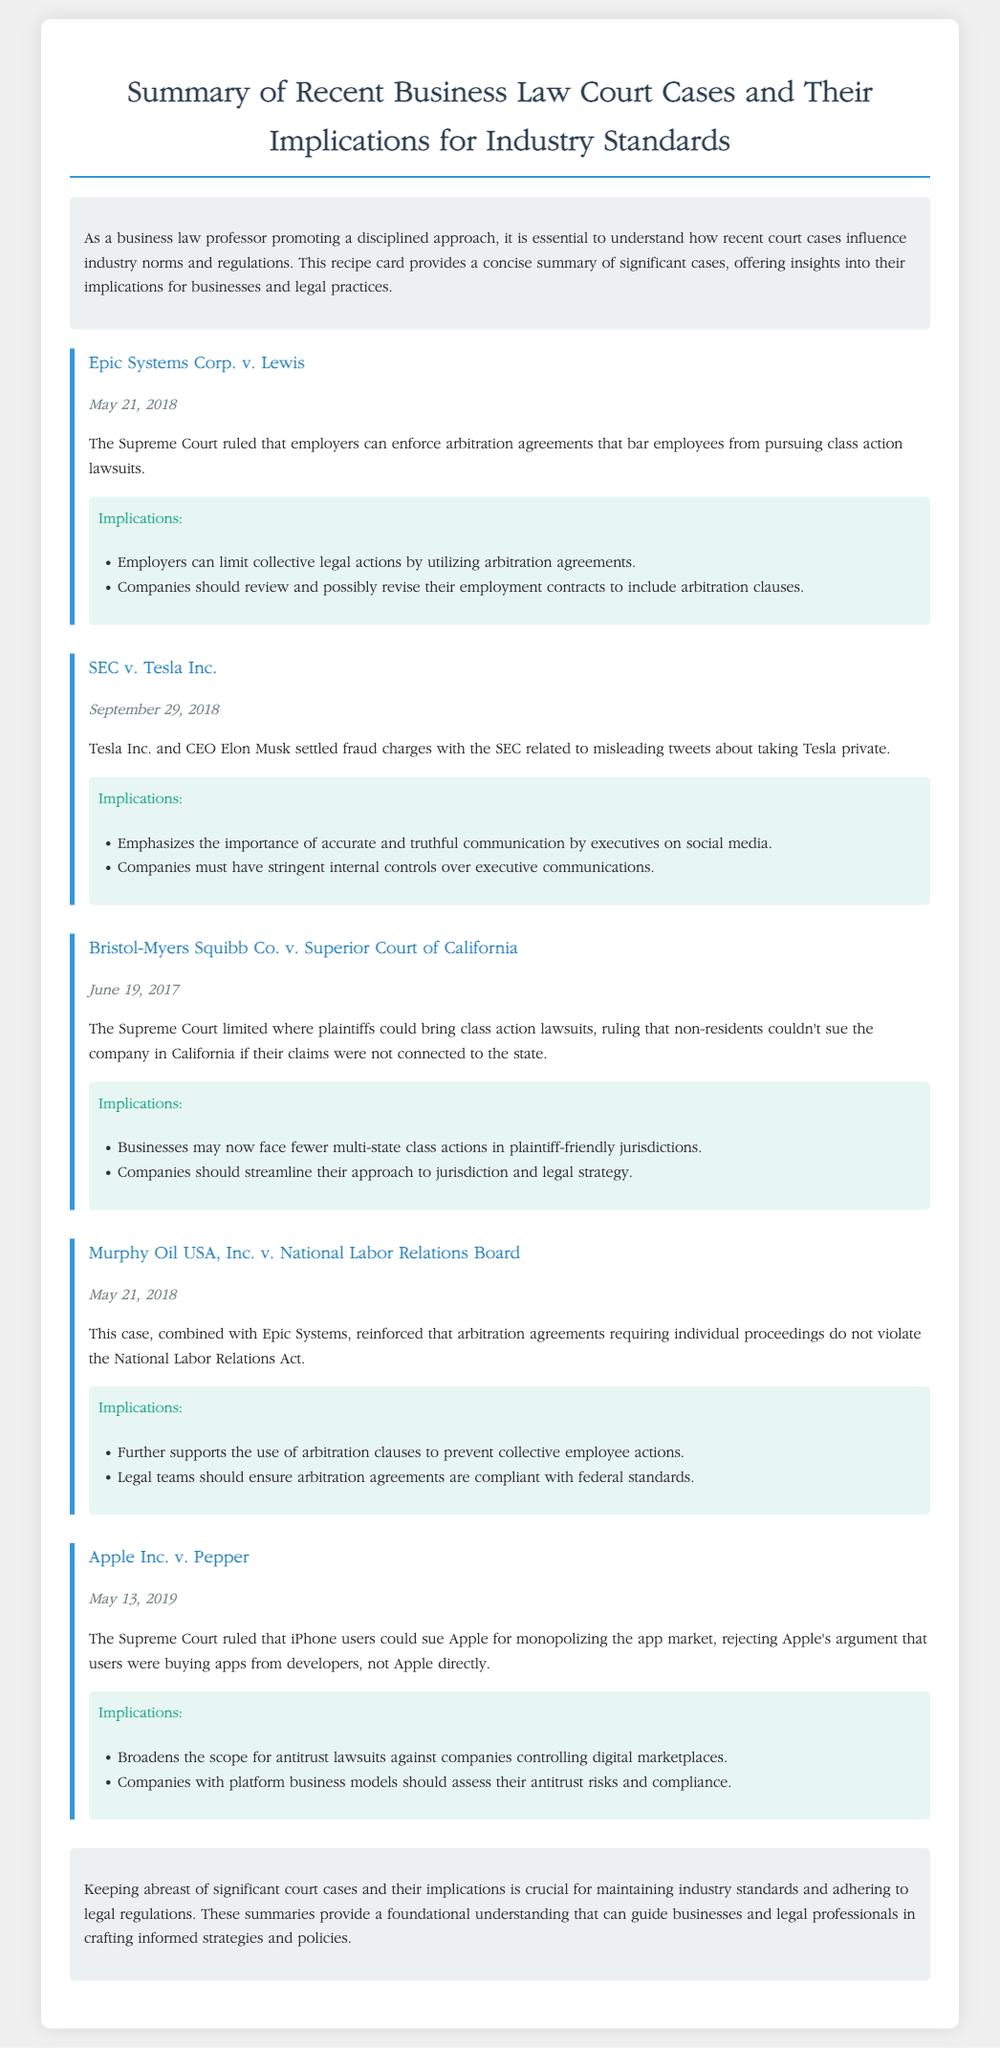What is the title of the document? The title is provided in the heading of the document, summarizing the content.
Answer: Summary of Recent Business Law Court Cases and Their Implications for Industry Standards When was Epic Systems Corp. v. Lewis decided? The case date is listed under the title of each case, indicating when the ruling was made.
Answer: May 21, 2018 Who settled fraud charges with the SEC? The document specifies which individual and company were involved in the case against the SEC.
Answer: Tesla Inc. and CEO Elon Musk What did the Supreme Court rule regarding Bristol-Myers Squibb Co.? The document outlines the court's decision on the jurisdiction for class action lawsuits.
Answer: Limited where plaintiffs could bring class action lawsuits What implications arise from the Epic Systems Corp. v. Lewis case? The implications are summarized underneath each case, outlining the effects on business practices.
Answer: Employers can limit collective legal actions by utilizing arbitration agreements How does the Apple Inc. v. Pepper case affect antitrust lawsuits? This question draws on information regarding the implications stated for the case and its broader effects.
Answer: Broadens the scope for antitrust lawsuits against companies controlling digital marketplaces What is the purpose of the introductory section? This section provides insight into the context and significance of the court cases discussed.
Answer: To understand how recent court cases influence industry norms and regulations What should companies do regarding their employment contracts after Epic Systems Corp. v. Lewis? The implications suggest specific actions businesses should consider based on the ruling.
Answer: Review and possibly revise their employment contracts to include arbitration clauses 